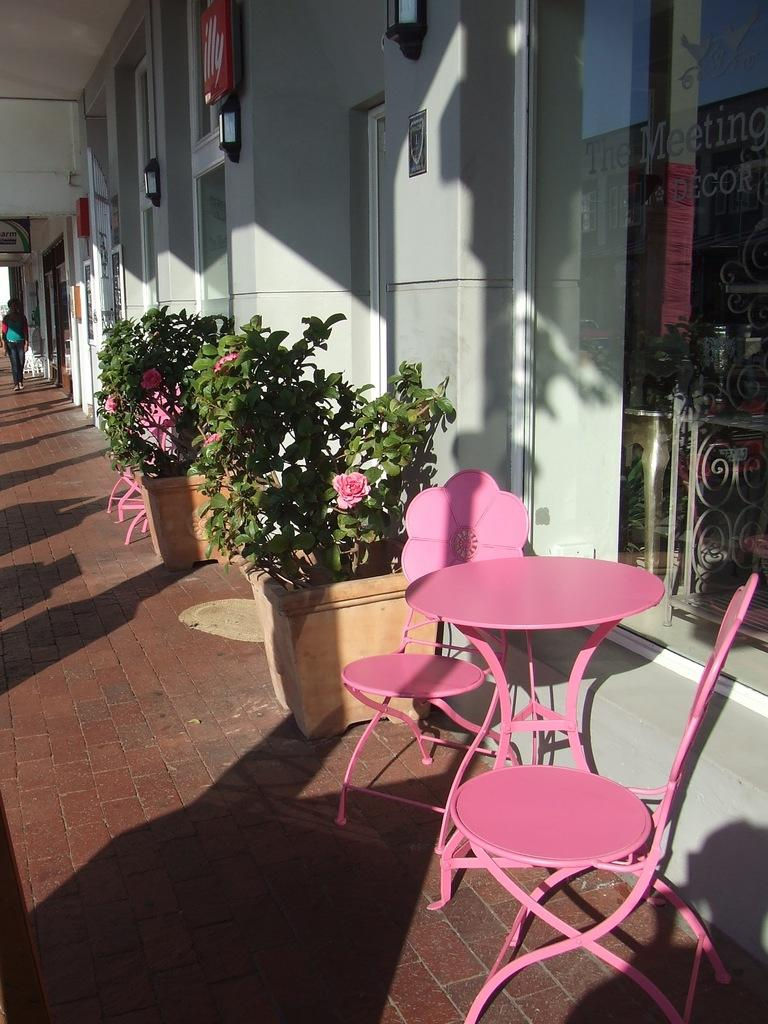What is the main subject of the image? There is a person on the ground in the image. What type of plants can be seen in the image? There are house plants with flowers in the image. What type of furniture is present in the image? There is a table and chairs in the image. What can be seen in the background of the image? There is a wall, lights, a roof, and some objects in the background of the image. What type of holiday is being celebrated in the image? There is no indication of a holiday being celebrated in the image. Can you see any ducks in the image? There are no ducks present in the image. 